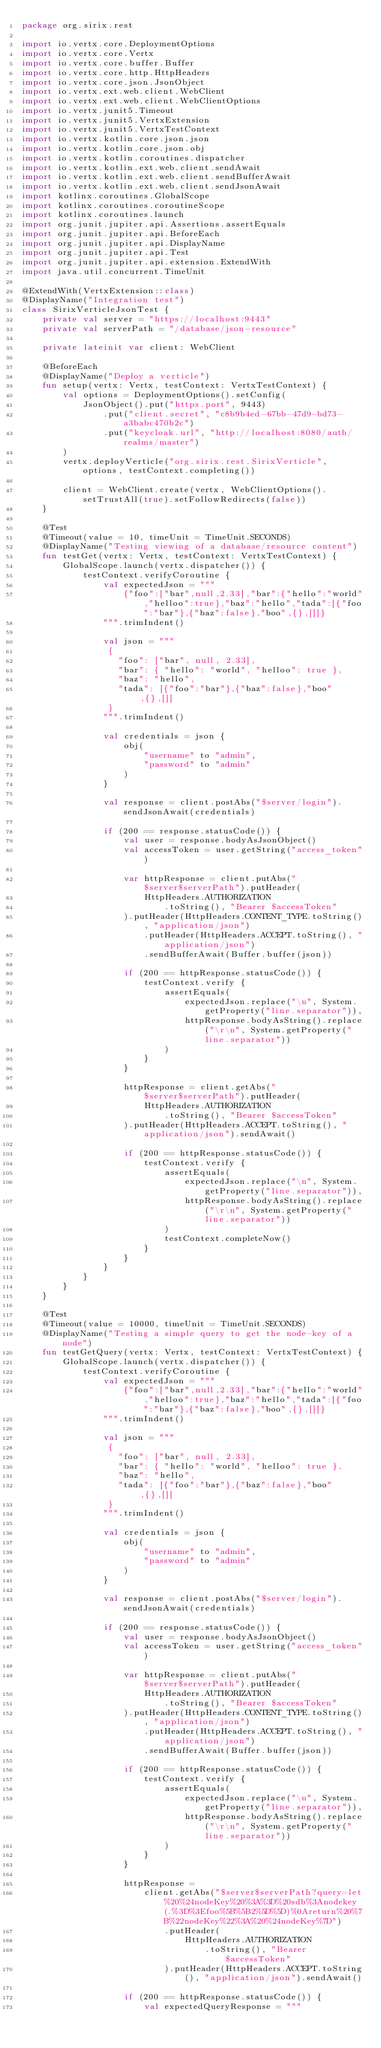<code> <loc_0><loc_0><loc_500><loc_500><_Kotlin_>package org.sirix.rest

import io.vertx.core.DeploymentOptions
import io.vertx.core.Vertx
import io.vertx.core.buffer.Buffer
import io.vertx.core.http.HttpHeaders
import io.vertx.core.json.JsonObject
import io.vertx.ext.web.client.WebClient
import io.vertx.ext.web.client.WebClientOptions
import io.vertx.junit5.Timeout
import io.vertx.junit5.VertxExtension
import io.vertx.junit5.VertxTestContext
import io.vertx.kotlin.core.json.json
import io.vertx.kotlin.core.json.obj
import io.vertx.kotlin.coroutines.dispatcher
import io.vertx.kotlin.ext.web.client.sendAwait
import io.vertx.kotlin.ext.web.client.sendBufferAwait
import io.vertx.kotlin.ext.web.client.sendJsonAwait
import kotlinx.coroutines.GlobalScope
import kotlinx.coroutines.coroutineScope
import kotlinx.coroutines.launch
import org.junit.jupiter.api.Assertions.assertEquals
import org.junit.jupiter.api.BeforeEach
import org.junit.jupiter.api.DisplayName
import org.junit.jupiter.api.Test
import org.junit.jupiter.api.extension.ExtendWith
import java.util.concurrent.TimeUnit

@ExtendWith(VertxExtension::class)
@DisplayName("Integration test")
class SirixVerticleJsonTest {
    private val server = "https://localhost:9443"
    private val serverPath = "/database/json-resource"

    private lateinit var client: WebClient

    @BeforeEach
    @DisplayName("Deploy a verticle")
    fun setup(vertx: Vertx, testContext: VertxTestContext) {
        val options = DeploymentOptions().setConfig(
            JsonObject().put("https.port", 9443)
                .put("client.secret", "c8b9b4ed-67bb-47d9-bd73-a3babc470b2c")
                .put("keycloak.url", "http://localhost:8080/auth/realms/master")
        )
        vertx.deployVerticle("org.sirix.rest.SirixVerticle", options, testContext.completing())

        client = WebClient.create(vertx, WebClientOptions().setTrustAll(true).setFollowRedirects(false))
    }

    @Test
    @Timeout(value = 10, timeUnit = TimeUnit.SECONDS)
    @DisplayName("Testing viewing of a database/resource content")
    fun testGet(vertx: Vertx, testContext: VertxTestContext) {
        GlobalScope.launch(vertx.dispatcher()) {
            testContext.verifyCoroutine {
                val expectedJson = """
                    {"foo":["bar",null,2.33],"bar":{"hello":"world","helloo":true},"baz":"hello","tada":[{"foo":"bar"},{"baz":false},"boo",{},[]]}
                """.trimIndent()

                val json = """
                 {
                   "foo": ["bar", null, 2.33],
                   "bar": { "hello": "world", "helloo": true },
                   "baz": "hello",
                   "tada": [{"foo":"bar"},{"baz":false},"boo",{},[]]
                 }
                """.trimIndent()

                val credentials = json {
                    obj(
                        "username" to "admin",
                        "password" to "admin"
                    )
                }

                val response = client.postAbs("$server/login").sendJsonAwait(credentials)

                if (200 == response.statusCode()) {
                    val user = response.bodyAsJsonObject()
                    val accessToken = user.getString("access_token")

                    var httpResponse = client.putAbs("$server$serverPath").putHeader(
                        HttpHeaders.AUTHORIZATION
                            .toString(), "Bearer $accessToken"
                    ).putHeader(HttpHeaders.CONTENT_TYPE.toString(), "application/json")
                        .putHeader(HttpHeaders.ACCEPT.toString(), "application/json")
                        .sendBufferAwait(Buffer.buffer(json))

                    if (200 == httpResponse.statusCode()) {
                        testContext.verify {
                            assertEquals(
                                expectedJson.replace("\n", System.getProperty("line.separator")),
                                httpResponse.bodyAsString().replace("\r\n", System.getProperty("line.separator"))
                            )
                        }
                    }

                    httpResponse = client.getAbs("$server$serverPath").putHeader(
                        HttpHeaders.AUTHORIZATION
                            .toString(), "Bearer $accessToken"
                    ).putHeader(HttpHeaders.ACCEPT.toString(), "application/json").sendAwait()

                    if (200 == httpResponse.statusCode()) {
                        testContext.verify {
                            assertEquals(
                                expectedJson.replace("\n", System.getProperty("line.separator")),
                                httpResponse.bodyAsString().replace("\r\n", System.getProperty("line.separator"))
                            )
                            testContext.completeNow()
                        }
                    }
                }
            }
        }
    }

    @Test
    @Timeout(value = 10000, timeUnit = TimeUnit.SECONDS)
    @DisplayName("Testing a simple query to get the node-key of a node")
    fun testGetQuery(vertx: Vertx, testContext: VertxTestContext) {
        GlobalScope.launch(vertx.dispatcher()) {
            testContext.verifyCoroutine {
                val expectedJson = """
                    {"foo":["bar",null,2.33],"bar":{"hello":"world","helloo":true},"baz":"hello","tada":[{"foo":"bar"},{"baz":false},"boo",{},[]]}
                """.trimIndent()

                val json = """
                 {
                   "foo": ["bar", null, 2.33],
                   "bar": { "hello": "world", "helloo": true },
                   "baz": "hello",
                   "tada": [{"foo":"bar"},{"baz":false},"boo",{},[]]
                 }
                """.trimIndent()

                val credentials = json {
                    obj(
                        "username" to "admin",
                        "password" to "admin"
                    )
                }

                val response = client.postAbs("$server/login").sendJsonAwait(credentials)

                if (200 == response.statusCode()) {
                    val user = response.bodyAsJsonObject()
                    val accessToken = user.getString("access_token")

                    var httpResponse = client.putAbs("$server$serverPath").putHeader(
                        HttpHeaders.AUTHORIZATION
                            .toString(), "Bearer $accessToken"
                    ).putHeader(HttpHeaders.CONTENT_TYPE.toString(), "application/json")
                        .putHeader(HttpHeaders.ACCEPT.toString(), "application/json")
                        .sendBufferAwait(Buffer.buffer(json))

                    if (200 == httpResponse.statusCode()) {
                        testContext.verify {
                            assertEquals(
                                expectedJson.replace("\n", System.getProperty("line.separator")),
                                httpResponse.bodyAsString().replace("\r\n", System.getProperty("line.separator"))
                            )
                        }
                    }

                    httpResponse =
                        client.getAbs("$server$serverPath?query=let%20%24nodeKey%20%3A%3D%20sdb%3Anodekey(.%3D%3Efoo%5B%5B2%5D%5D)%0Areturn%20%7B%22nodeKey%22%3A%20%24nodeKey%7D")
                            .putHeader(
                                HttpHeaders.AUTHORIZATION
                                    .toString(), "Bearer $accessToken"
                            ).putHeader(HttpHeaders.ACCEPT.toString(), "application/json").sendAwait()

                    if (200 == httpResponse.statusCode()) {
                        val expectedQueryResponse = """</code> 